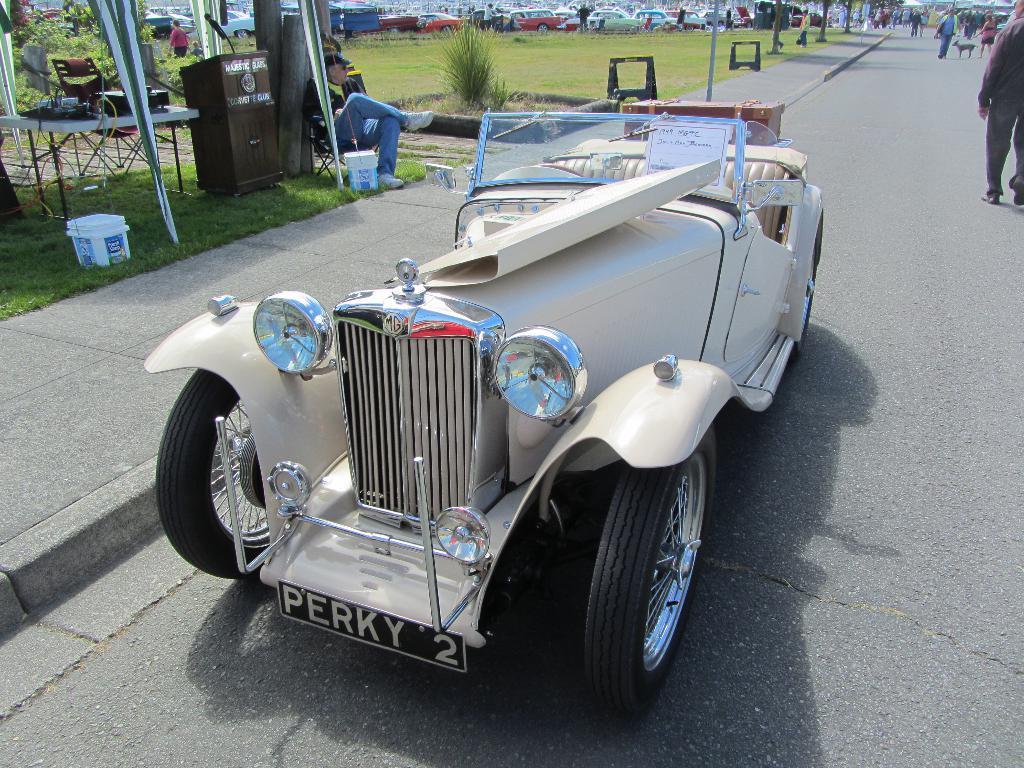Can you describe this image briefly? In this image we can see a few vehicles on the road, there are some people, plants, grass, buckets and some other objects on the ground, also we can see a podium, mic and a table, on the table, we can see some objects. 